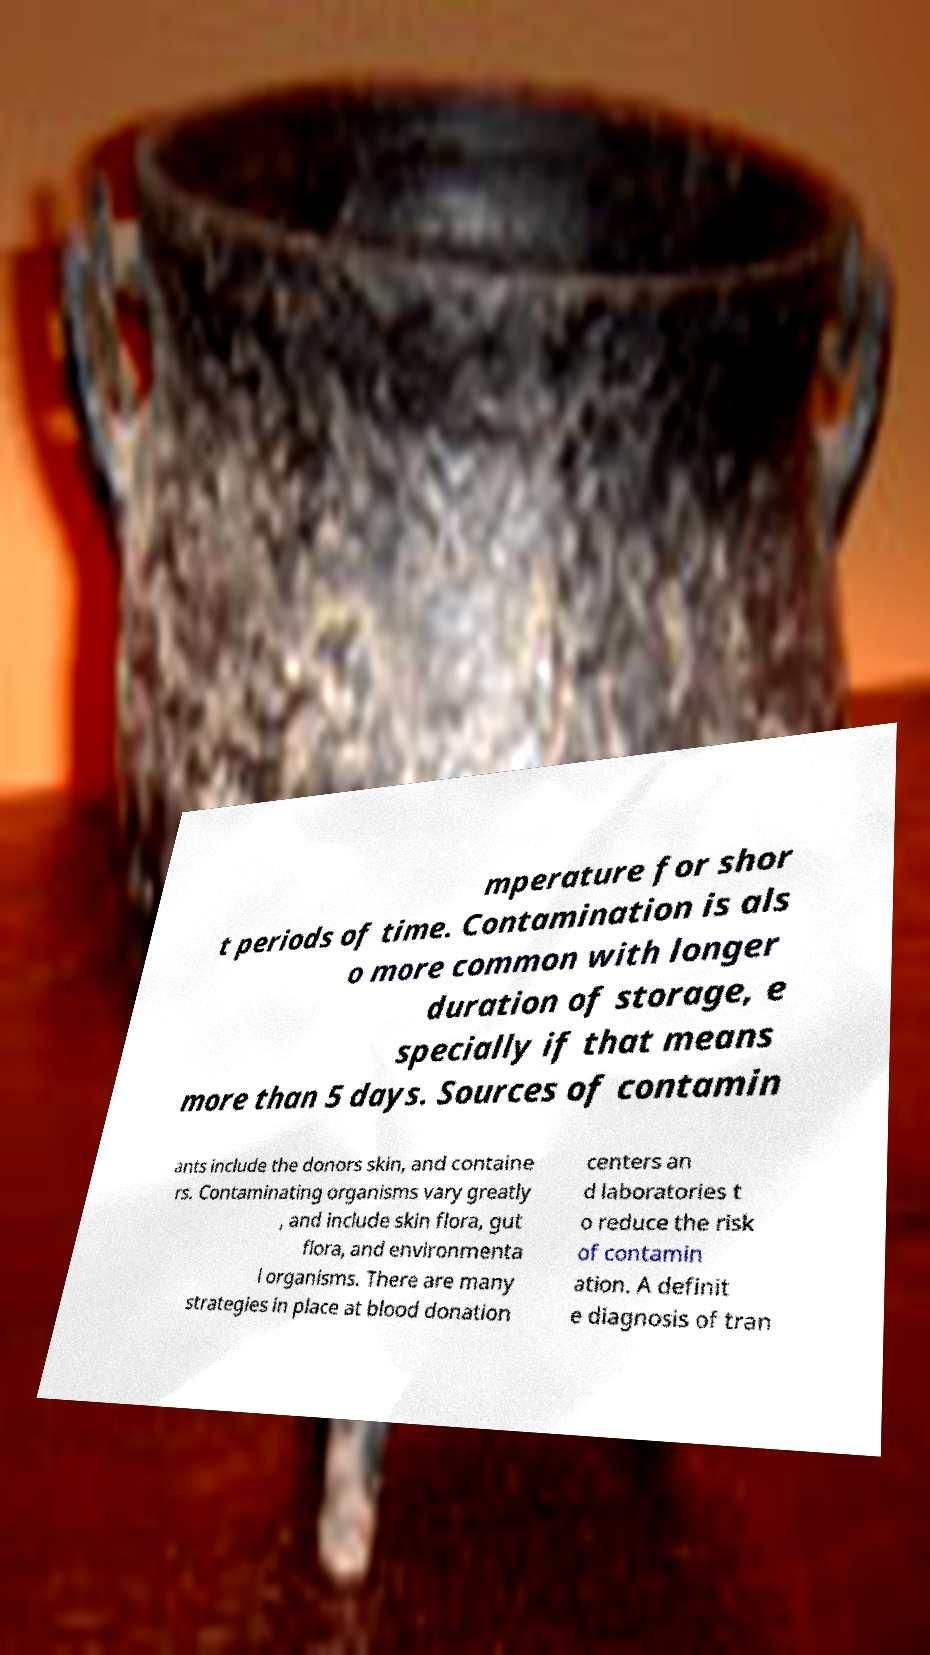Could you extract and type out the text from this image? mperature for shor t periods of time. Contamination is als o more common with longer duration of storage, e specially if that means more than 5 days. Sources of contamin ants include the donors skin, and containe rs. Contaminating organisms vary greatly , and include skin flora, gut flora, and environmenta l organisms. There are many strategies in place at blood donation centers an d laboratories t o reduce the risk of contamin ation. A definit e diagnosis of tran 